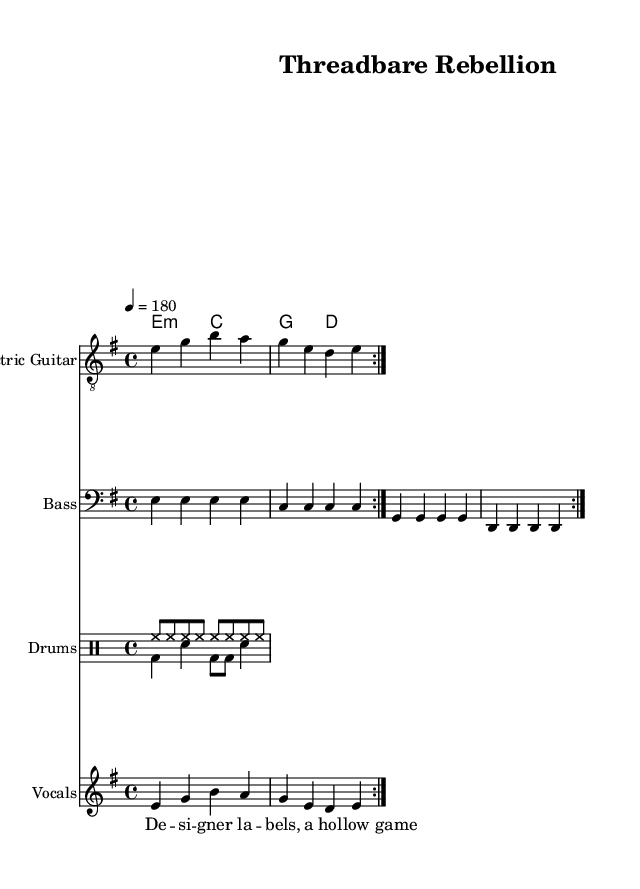What is the key signature of this music? The key signature is indicated in the global section where it states "e \minor". This means there is one sharp (F#).
Answer: e minor What is the time signature of this piece? The time signature is found in the global section as "4/4", meaning there are four beats in each measure and the quarter note gets one beat.
Answer: 4/4 What is the tempo marking for this piece? The tempo is indicated in the global section with "4 = 180", meaning the quarter note beats at a speed of 180 beats per minute.
Answer: 180 How many repetitions are there in the electric guitar section? The electric guitar part includes the directive "\repeat volta 2" indicating that the section is to be played twice.
Answer: 2 What is the first lyric line in the verse? The first lyric line is written in the verse section as "De -- si -- gner la -- bels, a hol -- low game". This is easily identified by looking at the lyrics associated with the staff.
Answer: De -- si -- gner la -- bels What is the instrument designated for the vocal part? The instrument for the vocal part is specified in the score by the label "Vocals", which is clearly stated in the section with the vocal staff.
Answer: Vocals 